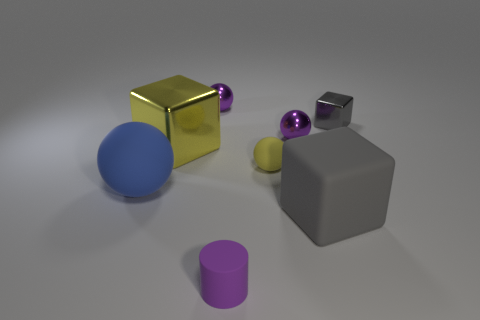What do the different colors of the objects suggest about their materials? The colors can give clues about their materials. For instance, the shiny yellow suggests metal, while the matte gray of the cube implies a rubbery texture. The blue, purple, and orange objects have a plastic-like sheen. These visual cues help us infer that these objects are made of different materials. 